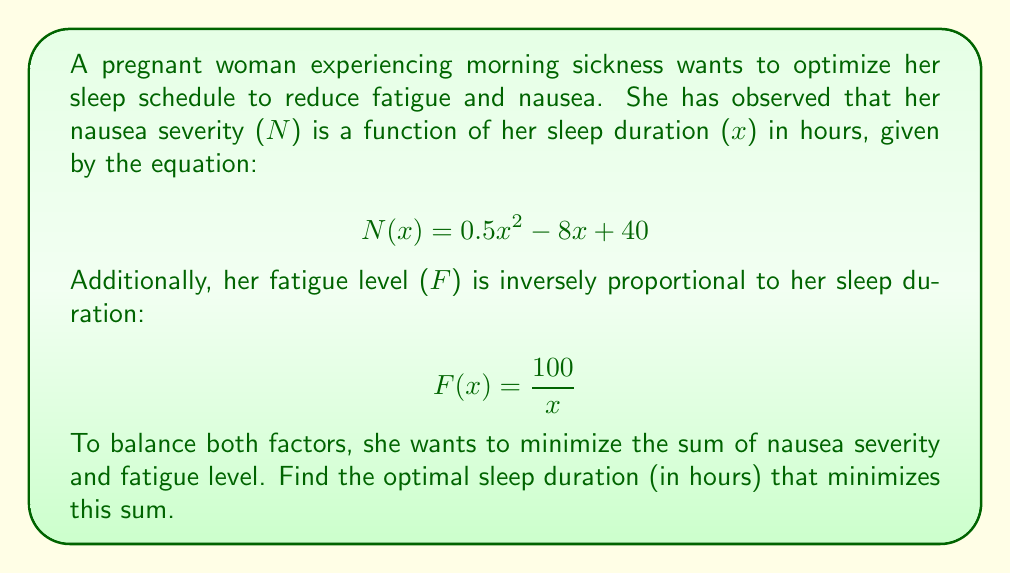Could you help me with this problem? To solve this optimization problem, we need to follow these steps:

1. Define the objective function to minimize:
   Let $T(x)$ be the total discomfort, which is the sum of nausea severity and fatigue level.
   $$ T(x) = N(x) + F(x) = 0.5x^2 - 8x + 40 + \frac{100}{x} $$

2. Find the derivative of $T(x)$:
   $$ T'(x) = x - 8 - \frac{100}{x^2} $$

3. Set the derivative equal to zero to find critical points:
   $$ x - 8 - \frac{100}{x^2} = 0 $$
   $$ x^3 - 8x^2 - 100 = 0 $$

4. Solve this cubic equation. While it's challenging to solve analytically, we can use numerical methods or graphing to find that there's one real solution between 9 and 10 hours.

5. Using a calculator or computer algebra system, we can find the precise solution:
   $$ x \approx 9.69 \text{ hours} $$

6. Verify that this is a minimum by checking the second derivative:
   $$ T''(x) = 1 + \frac{200}{x^3} $$
   At $x = 9.69$, $T''(x) > 0$, confirming it's a local minimum.

7. Check the endpoints of the domain (assuming sleep duration is between 4 and 12 hours) to ensure this is a global minimum.

Therefore, the optimal sleep duration to minimize the sum of nausea severity and fatigue is approximately 9.69 hours.
Answer: The optimal sleep duration is approximately 9.69 hours. 